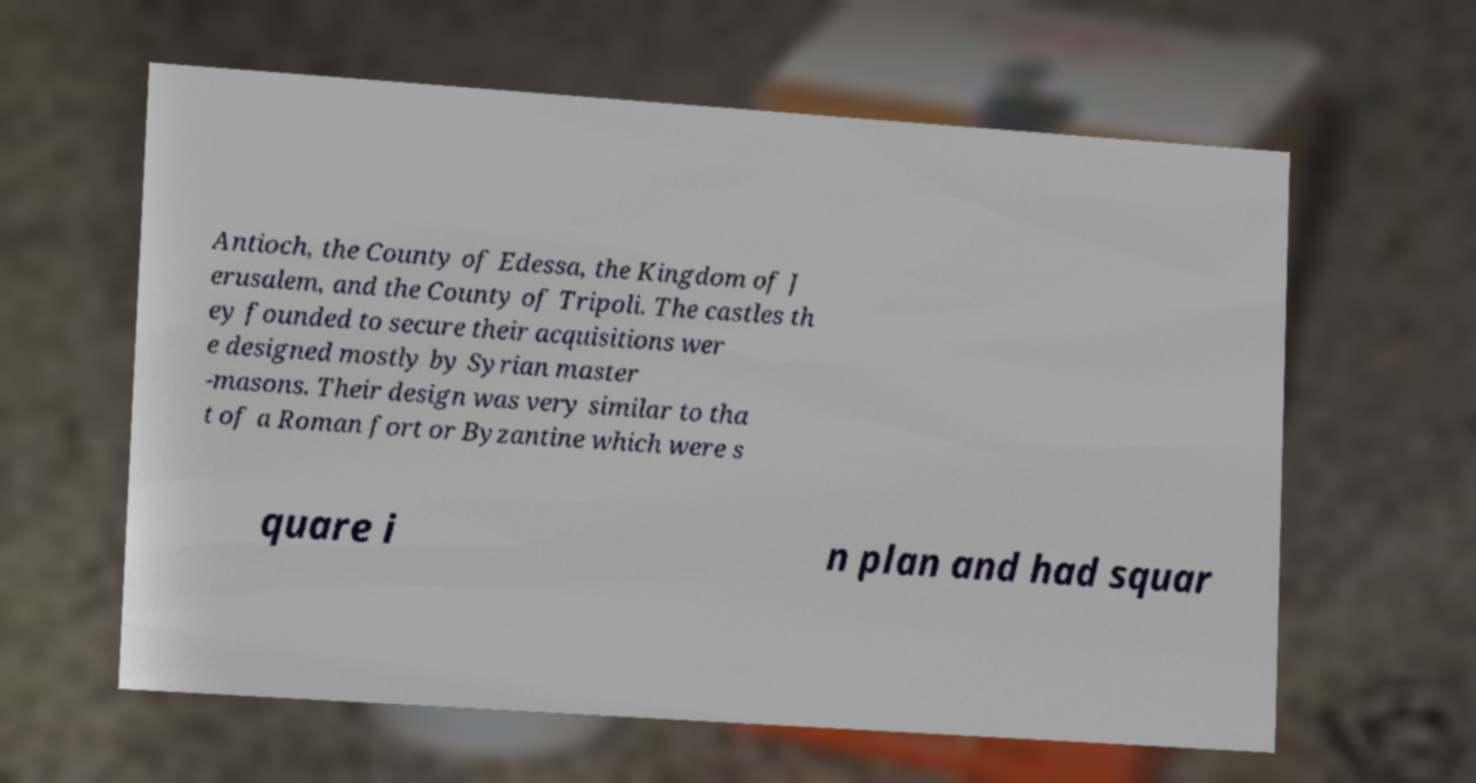There's text embedded in this image that I need extracted. Can you transcribe it verbatim? Antioch, the County of Edessa, the Kingdom of J erusalem, and the County of Tripoli. The castles th ey founded to secure their acquisitions wer e designed mostly by Syrian master -masons. Their design was very similar to tha t of a Roman fort or Byzantine which were s quare i n plan and had squar 